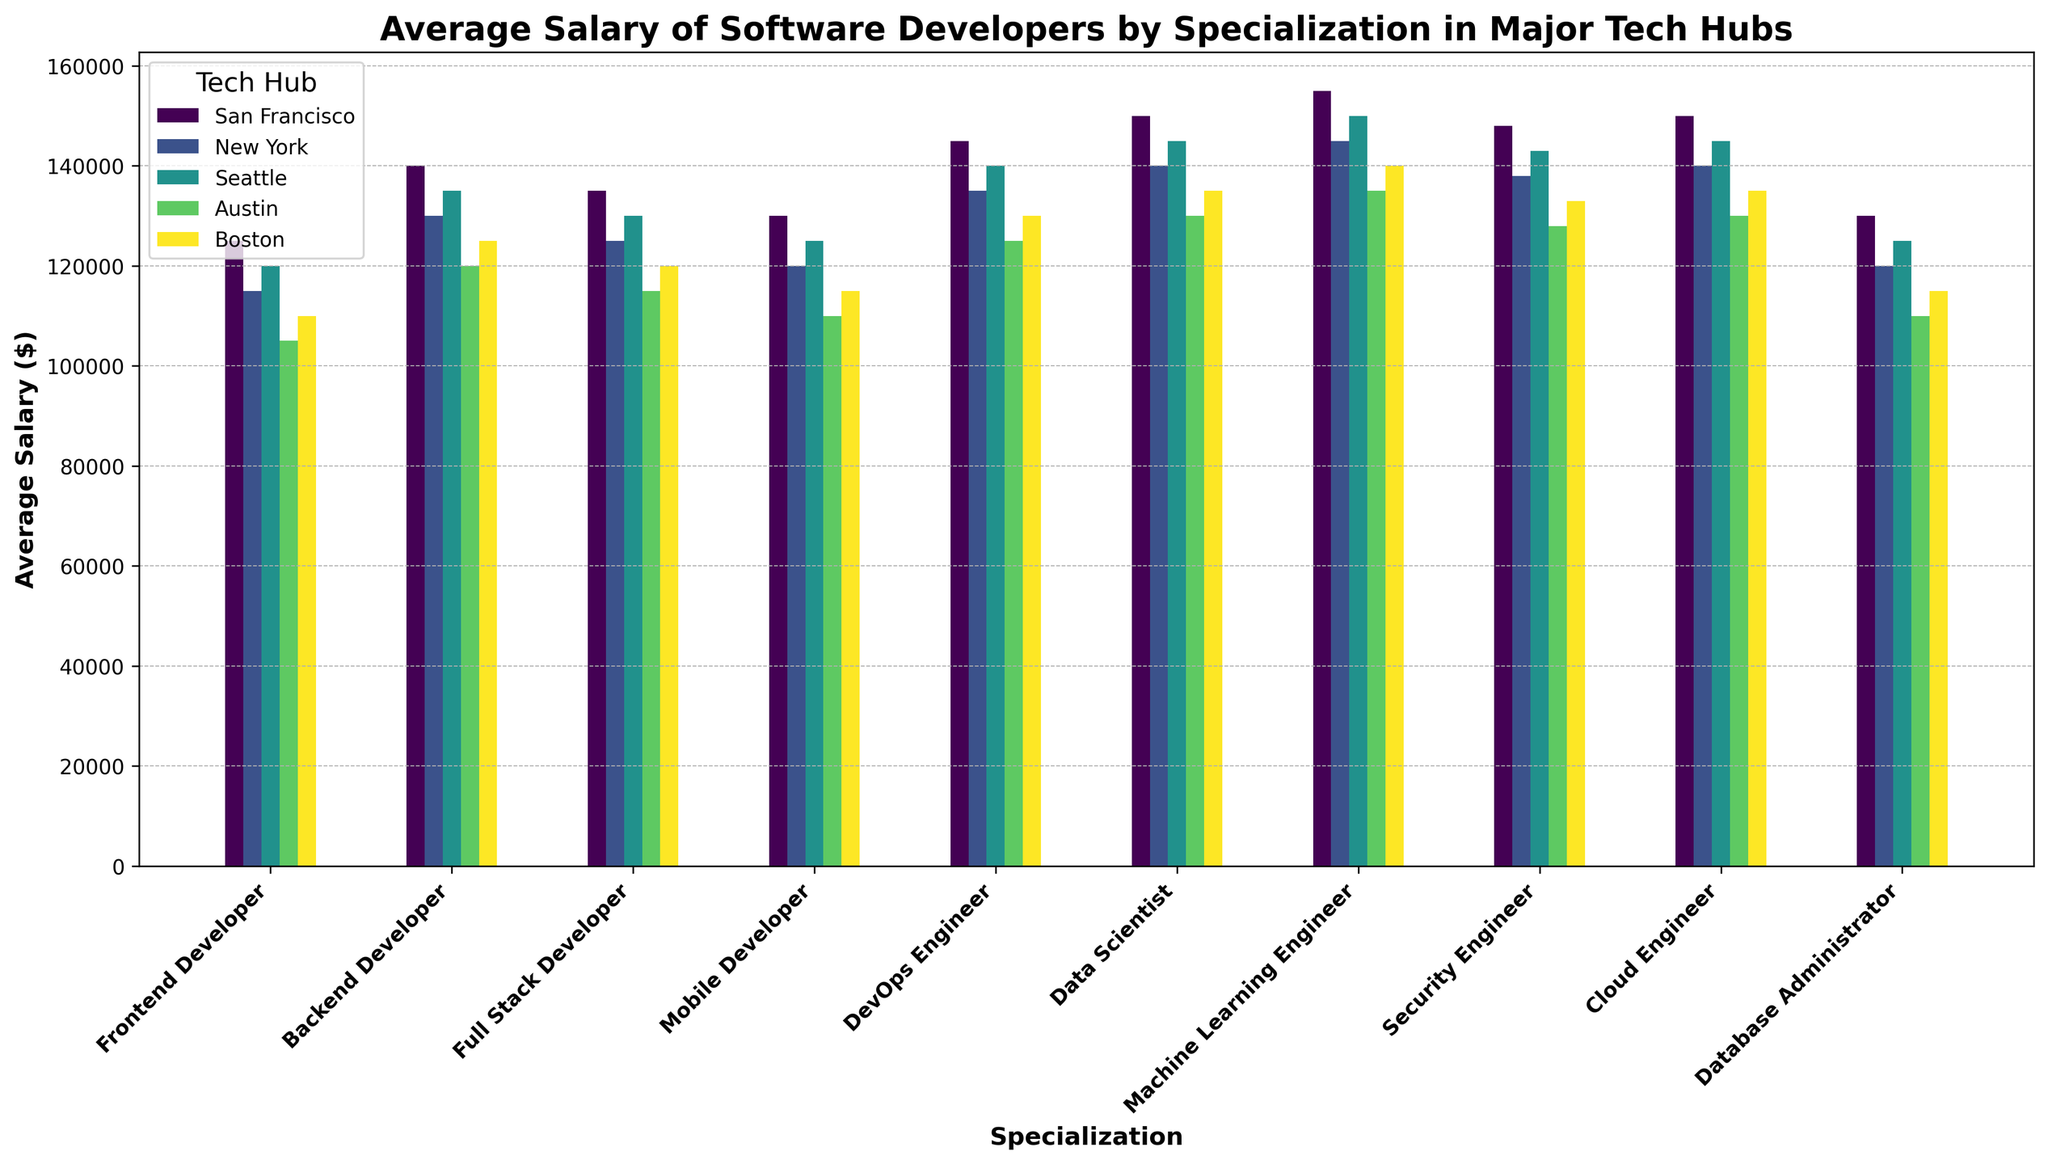Which specialization has the highest average salary overall? To determine the specialization with the highest average salary overall, compare the salary across all specializations in all locations. The highest number is associated with Machine Learning Engineers in San Francisco ($155,000).
Answer: Machine Learning Engineer Which tech hub offers the highest salary for Data Scientists? Look at the bar heights for Data Scientists across all tech hubs. The highest bar indicates the highest salary, which is in San Francisco ($150,000).
Answer: San Francisco What is the difference in average salary between Backend Developers in San Francisco and New York? Identify the salaries for Backend Developers in both locations. Subtract New York's salary ($130,000) from San Francisco's salary ($140,000). $140,000 - $130,000 = $10,000.
Answer: $10,000 Among the given tech hubs, which one offers the lowest salary for Frontend Developers and what is it? Examine the bars for Frontend Developers across all tech hubs. The shortest bar represents the lowest salary, which is in Austin ($105,000).
Answer: Austin, $105,000 What is the average salary of DevOps Engineers across all tech hubs? Add the average salaries of DevOps Engineers in all tech hubs and divide by the number of hubs: ($145,000 + $135,000 + $140,000 + $125,000 + $130,000)/5. Calculate: $675,000 / 5 = $135,000.
Answer: $135,000 Which specialization has the smallest salary range across the tech hubs? Calculate the range (max salary - min salary) for each specialization and compare. Frontend Developers have the smallest range: max $125,000, min $105,000, range $125,000 - $105,000 = $20,000.
Answer: Frontend Developer How many specializations have an average salary of $130,000 or more in Seattle? Count the specializations in Seattle where the salary is $130,000 or more: Backend Developer ($135,000), Full Stack Developer ($130,000), DevOps Engineer ($140,000), Data Scientist ($145,000), Machine Learning Engineer ($150,000), Security Engineer ($143,000), Cloud Engineer ($145,000). Total: 7 specializations.
Answer: 7 Which tech hub shows the highest average salary for Cloud Engineers? Find and compare the average salaries for Cloud Engineers across all tech hubs. The highest salary is in San Francisco and Seattle ($150,000 each).
Answer: San Francisco and Seattle If a company wants to hire a Database Administrator and Data Scientist, which tech hub offers the lowest combined average salary for both positions? Add the average salaries of Database Administrators and Data Scientists in each tech hub and find the smallest sum. Austin offers the lowest combined salary: $110,000 (Database Administrator) + $130,000 (Data Scientist) = $240,000.
Answer: Austin 